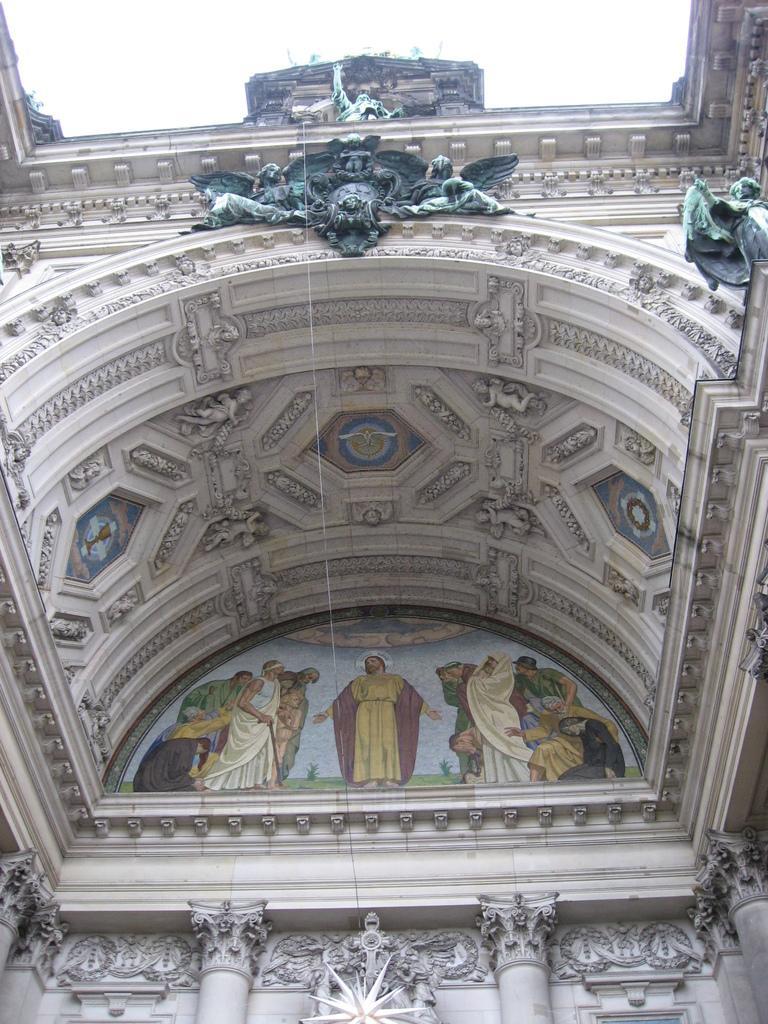Please provide a concise description of this image. In the center of the image there is a building and we can see a painting on the wall. At the bottom there are pillars. At the top there are statues and sky. 